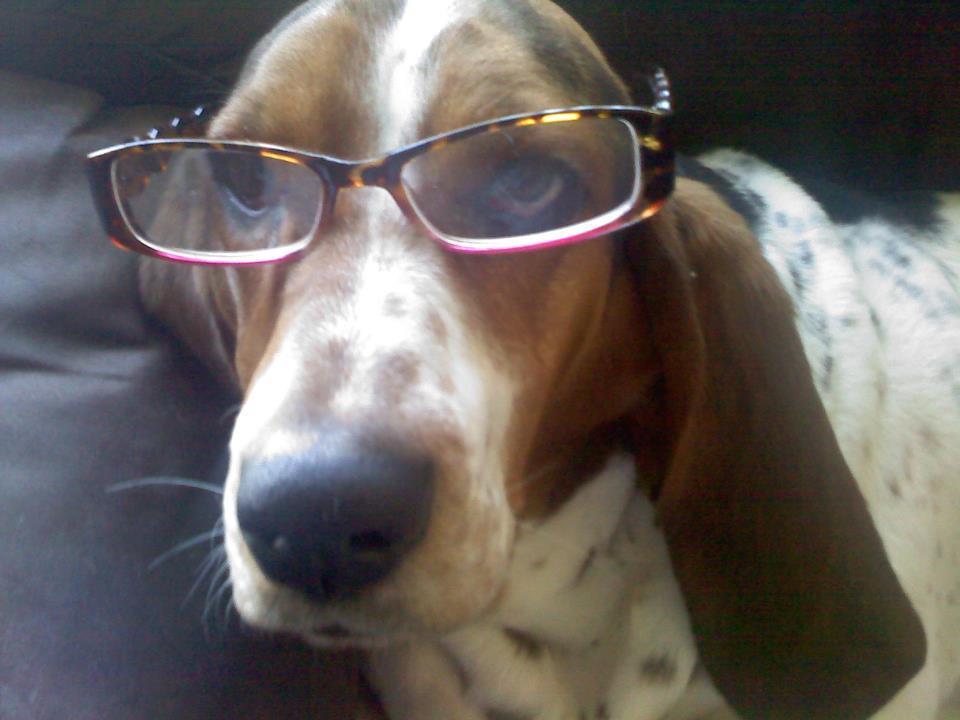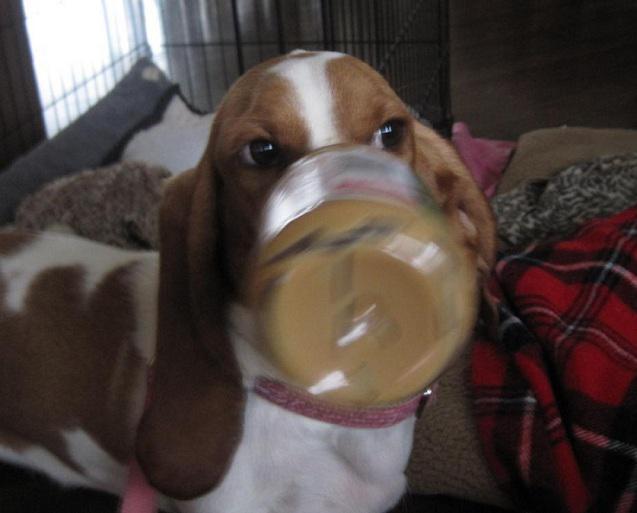The first image is the image on the left, the second image is the image on the right. For the images displayed, is the sentence "Each image includes exactly one basset hound, which faces mostly forward, and at least one hound has an object in front of part of its face and touching part of its face." factually correct? Answer yes or no. Yes. 